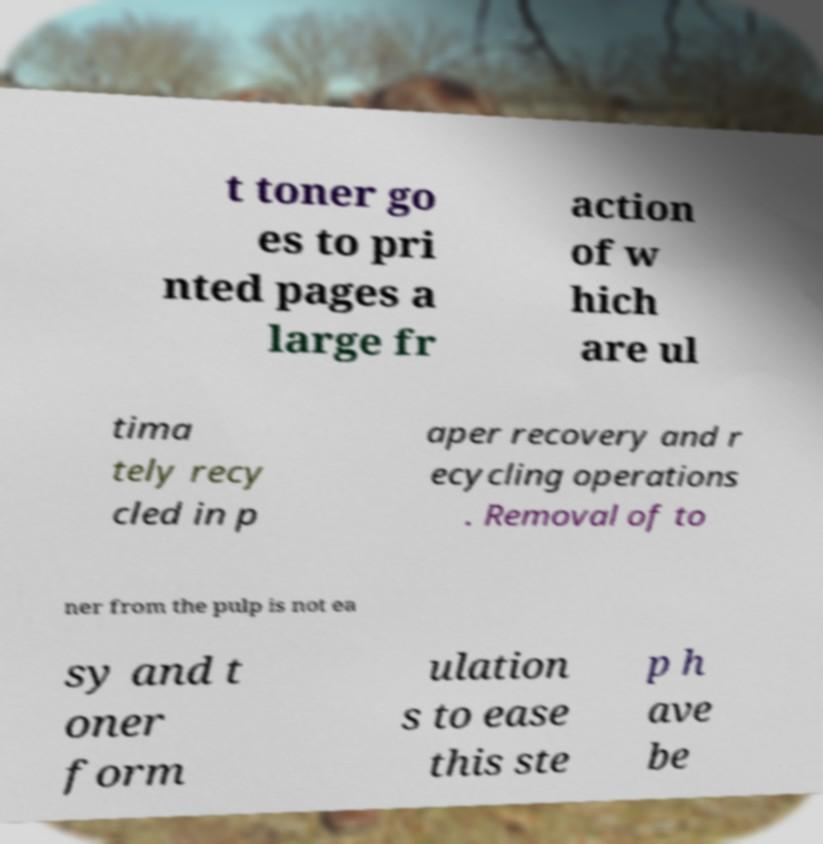Can you read and provide the text displayed in the image?This photo seems to have some interesting text. Can you extract and type it out for me? t toner go es to pri nted pages a large fr action of w hich are ul tima tely recy cled in p aper recovery and r ecycling operations . Removal of to ner from the pulp is not ea sy and t oner form ulation s to ease this ste p h ave be 